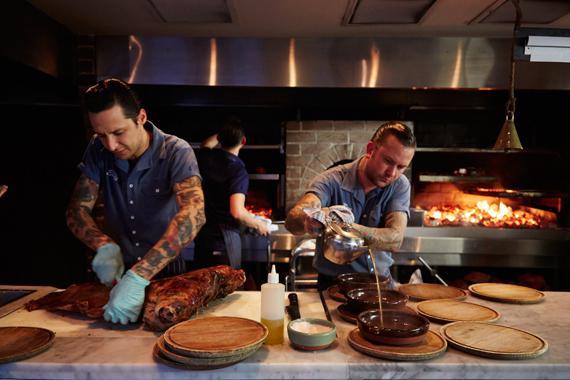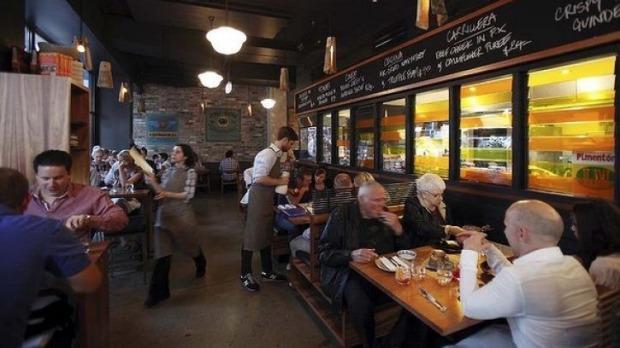The first image is the image on the left, the second image is the image on the right. For the images displayed, is the sentence "They are roasting pigs in one of the images." factually correct? Answer yes or no. No. The first image is the image on the left, the second image is the image on the right. Evaluate the accuracy of this statement regarding the images: "There are pigs surrounding a fire pit.". Is it true? Answer yes or no. No. 